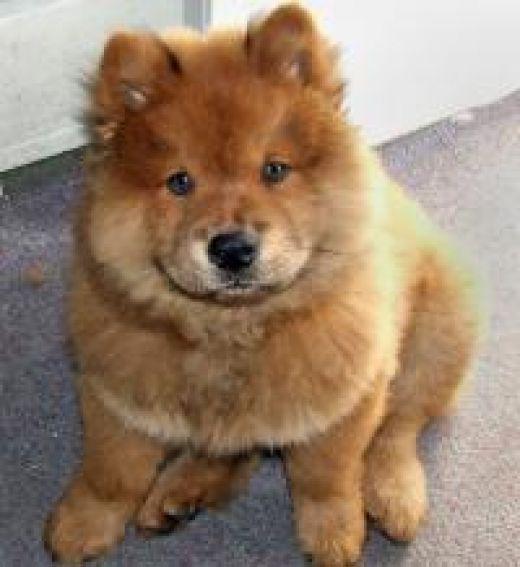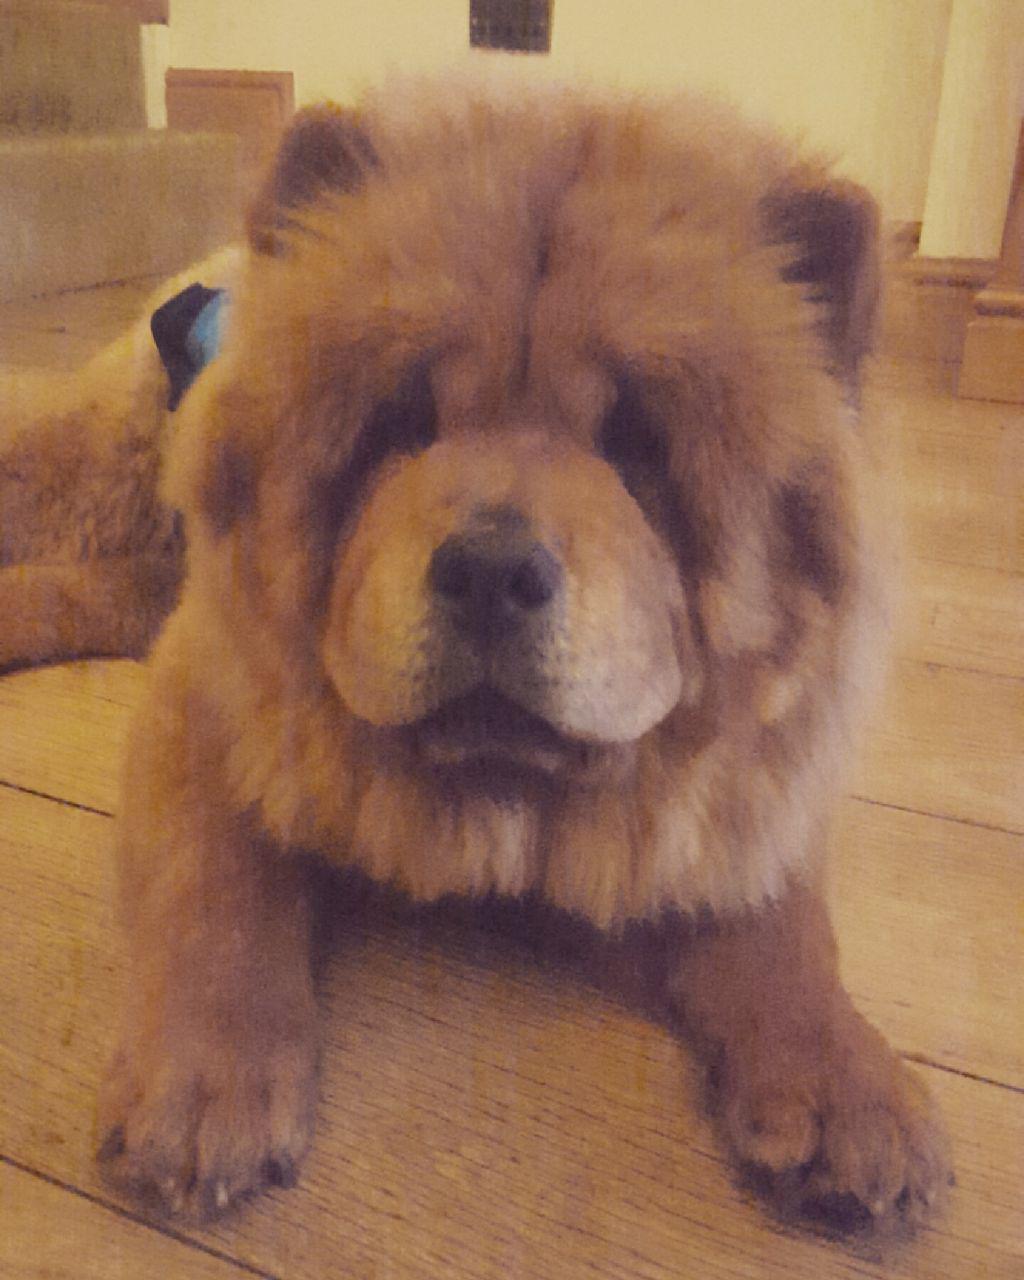The first image is the image on the left, the second image is the image on the right. Assess this claim about the two images: "The dog in the image on the right is positioned on a wooden surface.". Correct or not? Answer yes or no. Yes. The first image is the image on the left, the second image is the image on the right. For the images shown, is this caption "All dogs shown are chow puppies, one puppy is standing with its body in profile, one puppy has its front paws extended, and at least one of the puppies has a black muzzle." true? Answer yes or no. No. 